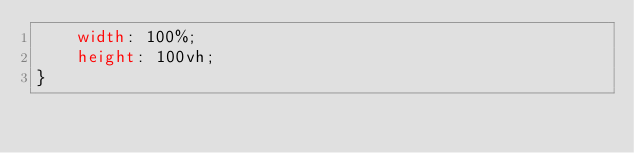<code> <loc_0><loc_0><loc_500><loc_500><_CSS_>    width: 100%;
    height: 100vh;
}</code> 